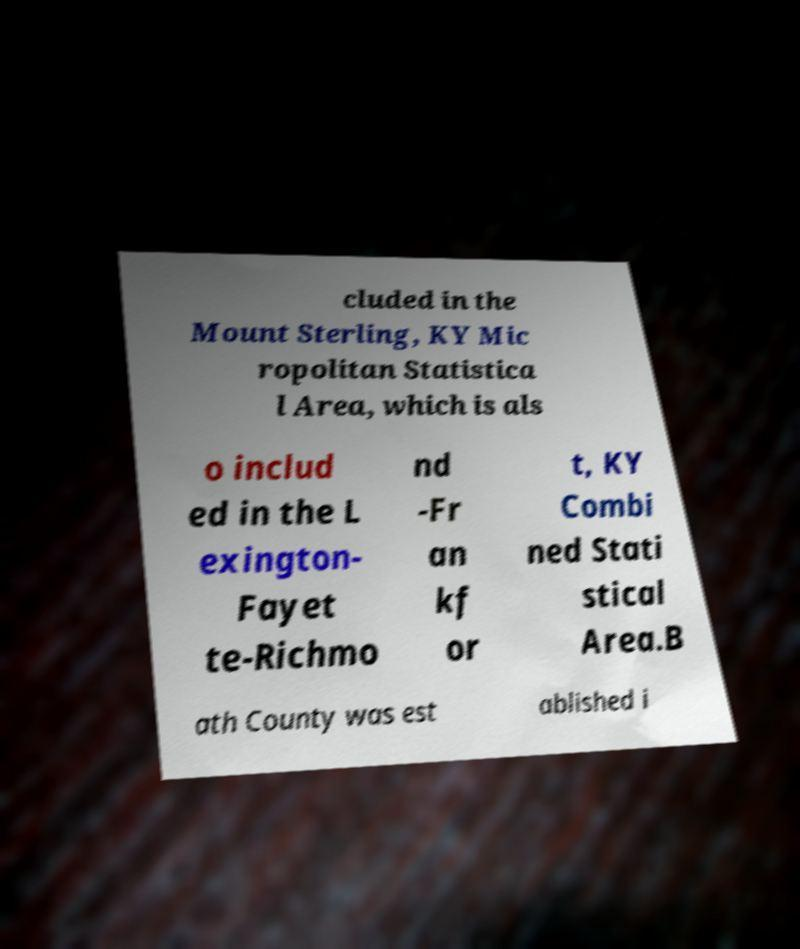Can you read and provide the text displayed in the image?This photo seems to have some interesting text. Can you extract and type it out for me? cluded in the Mount Sterling, KY Mic ropolitan Statistica l Area, which is als o includ ed in the L exington- Fayet te-Richmo nd -Fr an kf or t, KY Combi ned Stati stical Area.B ath County was est ablished i 